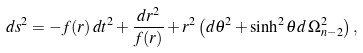Convert formula to latex. <formula><loc_0><loc_0><loc_500><loc_500>d s ^ { 2 } = - f ( r ) \, d t ^ { 2 } + \frac { d r ^ { 2 } } { f ( r ) } + r ^ { 2 } \left ( d \theta ^ { 2 } + \sinh ^ { 2 } \theta d \, \Omega _ { n - 2 } ^ { 2 } \right ) ,</formula> 